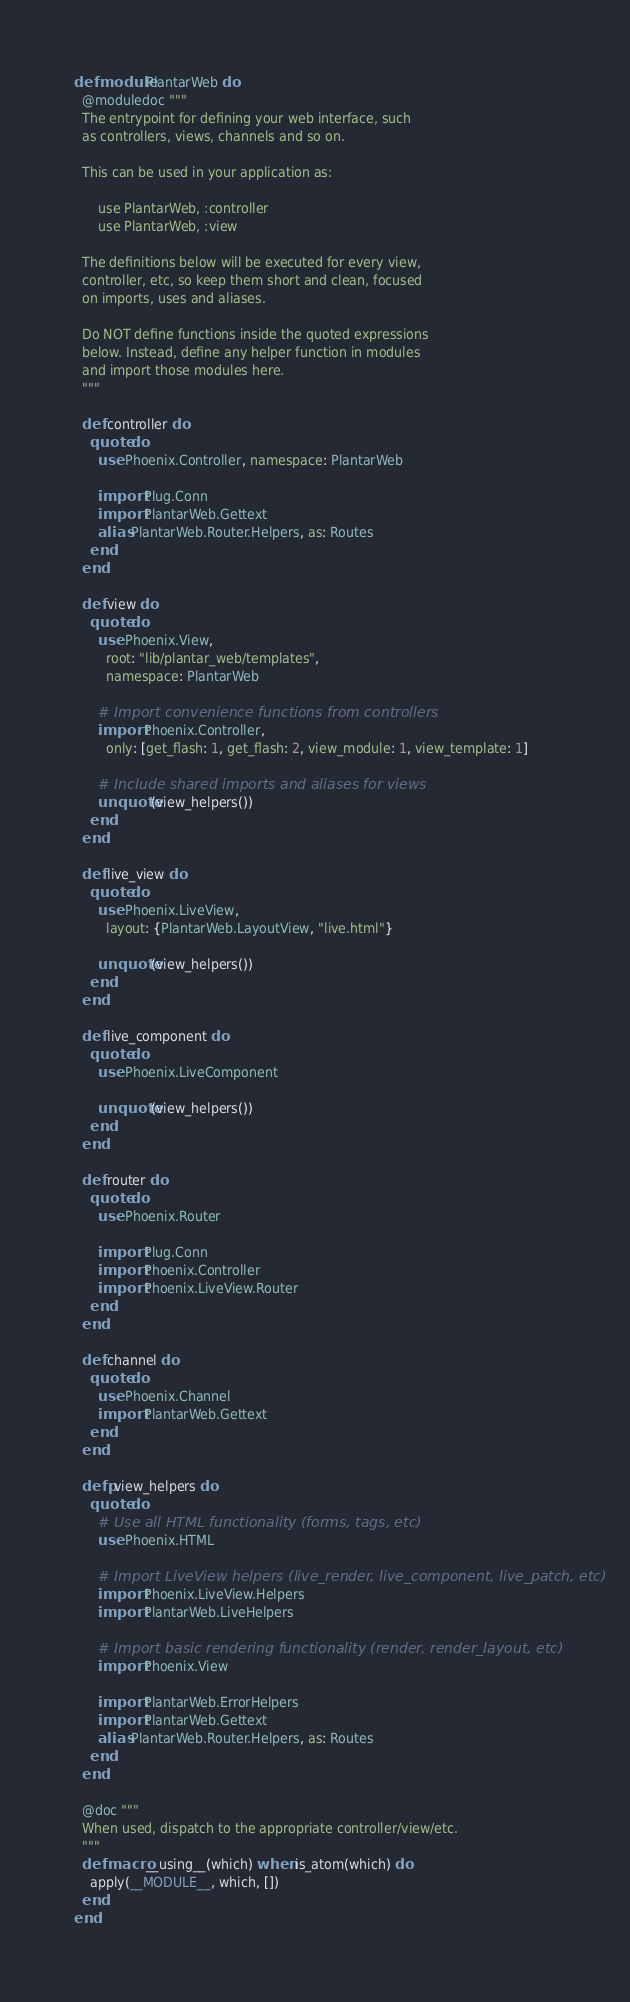<code> <loc_0><loc_0><loc_500><loc_500><_Elixir_>defmodule PlantarWeb do
  @moduledoc """
  The entrypoint for defining your web interface, such
  as controllers, views, channels and so on.

  This can be used in your application as:

      use PlantarWeb, :controller
      use PlantarWeb, :view

  The definitions below will be executed for every view,
  controller, etc, so keep them short and clean, focused
  on imports, uses and aliases.

  Do NOT define functions inside the quoted expressions
  below. Instead, define any helper function in modules
  and import those modules here.
  """

  def controller do
    quote do
      use Phoenix.Controller, namespace: PlantarWeb

      import Plug.Conn
      import PlantarWeb.Gettext
      alias PlantarWeb.Router.Helpers, as: Routes
    end
  end

  def view do
    quote do
      use Phoenix.View,
        root: "lib/plantar_web/templates",
        namespace: PlantarWeb

      # Import convenience functions from controllers
      import Phoenix.Controller,
        only: [get_flash: 1, get_flash: 2, view_module: 1, view_template: 1]

      # Include shared imports and aliases for views
      unquote(view_helpers())
    end
  end

  def live_view do
    quote do
      use Phoenix.LiveView,
        layout: {PlantarWeb.LayoutView, "live.html"}

      unquote(view_helpers())
    end
  end

  def live_component do
    quote do
      use Phoenix.LiveComponent

      unquote(view_helpers())
    end
  end

  def router do
    quote do
      use Phoenix.Router

      import Plug.Conn
      import Phoenix.Controller
      import Phoenix.LiveView.Router
    end
  end

  def channel do
    quote do
      use Phoenix.Channel
      import PlantarWeb.Gettext
    end
  end

  defp view_helpers do
    quote do
      # Use all HTML functionality (forms, tags, etc)
      use Phoenix.HTML

      # Import LiveView helpers (live_render, live_component, live_patch, etc)
      import Phoenix.LiveView.Helpers
      import PlantarWeb.LiveHelpers

      # Import basic rendering functionality (render, render_layout, etc)
      import Phoenix.View

      import PlantarWeb.ErrorHelpers
      import PlantarWeb.Gettext
      alias PlantarWeb.Router.Helpers, as: Routes
    end
  end

  @doc """
  When used, dispatch to the appropriate controller/view/etc.
  """
  defmacro __using__(which) when is_atom(which) do
    apply(__MODULE__, which, [])
  end
end
</code> 